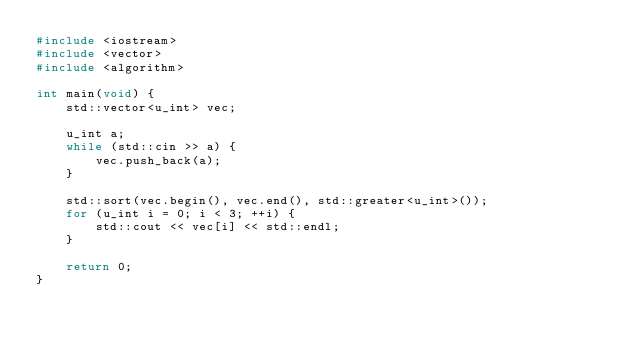<code> <loc_0><loc_0><loc_500><loc_500><_C++_>#include <iostream>
#include <vector>
#include <algorithm>

int main(void) {
    std::vector<u_int> vec;

    u_int a;
    while (std::cin >> a) {
        vec.push_back(a);
    }

    std::sort(vec.begin(), vec.end(), std::greater<u_int>());
    for (u_int i = 0; i < 3; ++i) {
        std::cout << vec[i] << std::endl;
    }

    return 0;
}</code> 